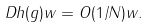<formula> <loc_0><loc_0><loc_500><loc_500>\| D h ( g ) w \| = O ( 1 / N ) \| w \| .</formula> 